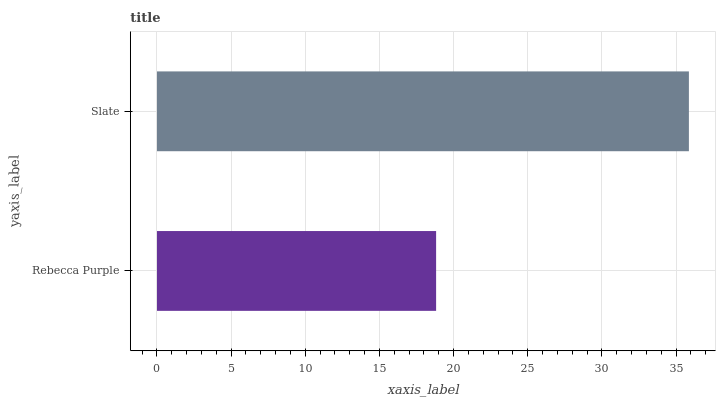Is Rebecca Purple the minimum?
Answer yes or no. Yes. Is Slate the maximum?
Answer yes or no. Yes. Is Slate the minimum?
Answer yes or no. No. Is Slate greater than Rebecca Purple?
Answer yes or no. Yes. Is Rebecca Purple less than Slate?
Answer yes or no. Yes. Is Rebecca Purple greater than Slate?
Answer yes or no. No. Is Slate less than Rebecca Purple?
Answer yes or no. No. Is Slate the high median?
Answer yes or no. Yes. Is Rebecca Purple the low median?
Answer yes or no. Yes. Is Rebecca Purple the high median?
Answer yes or no. No. Is Slate the low median?
Answer yes or no. No. 